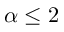Convert formula to latex. <formula><loc_0><loc_0><loc_500><loc_500>\alpha \leq 2</formula> 